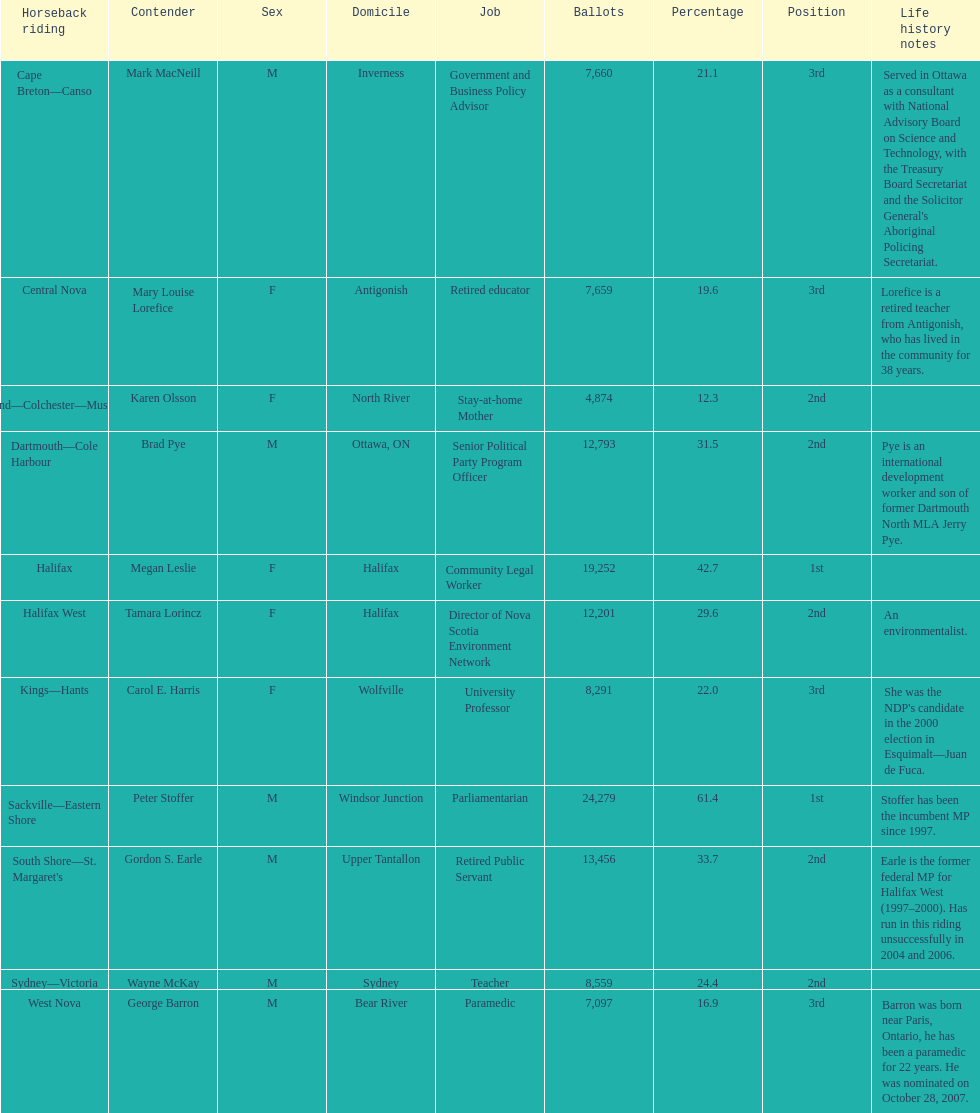What is the overall count of candidates? 11. 